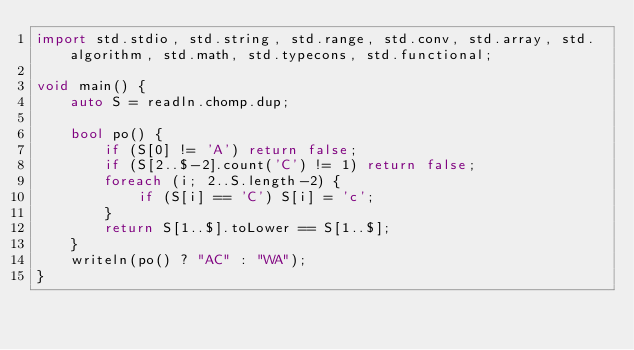Convert code to text. <code><loc_0><loc_0><loc_500><loc_500><_D_>import std.stdio, std.string, std.range, std.conv, std.array, std.algorithm, std.math, std.typecons, std.functional;

void main() {
    auto S = readln.chomp.dup;

    bool po() {
        if (S[0] != 'A') return false;
        if (S[2..$-2].count('C') != 1) return false;
        foreach (i; 2..S.length-2) {
            if (S[i] == 'C') S[i] = 'c';
        }
        return S[1..$].toLower == S[1..$];
    }
    writeln(po() ? "AC" : "WA");
}

</code> 